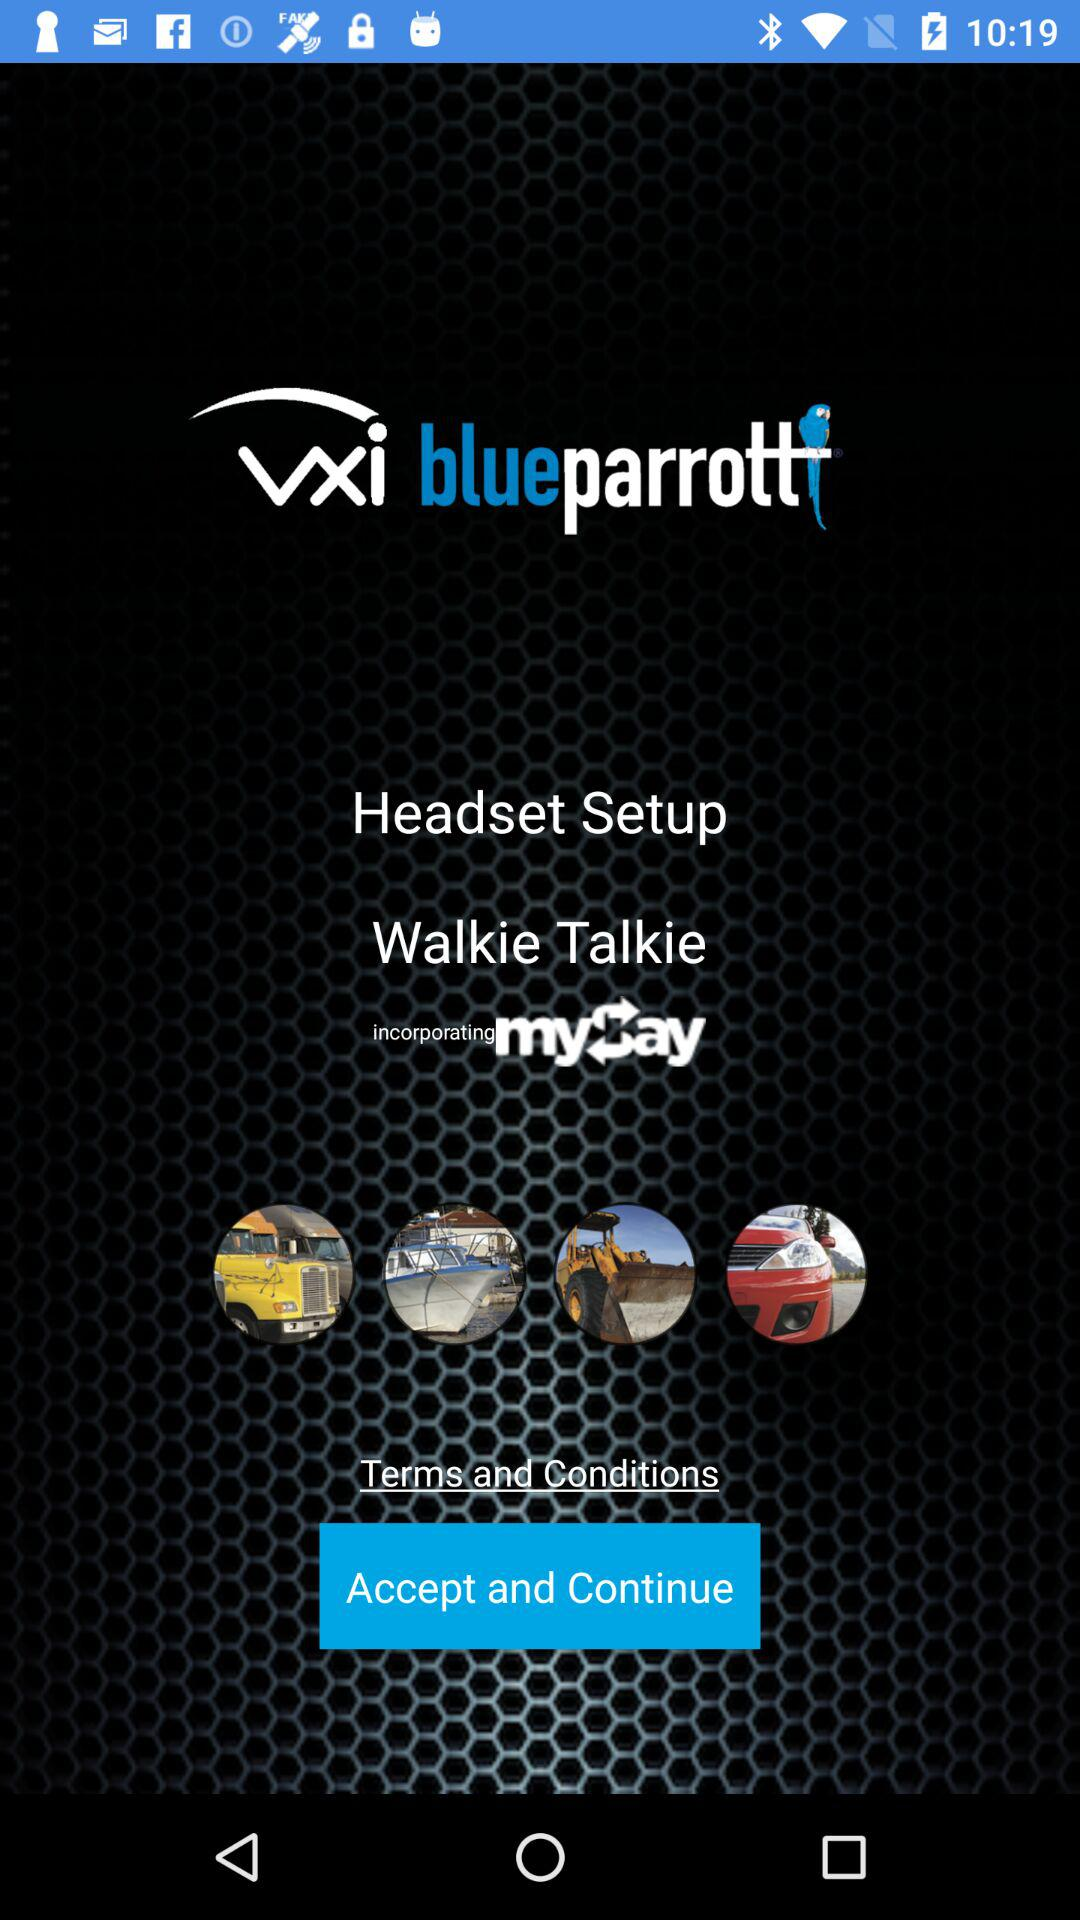What is the name of the application? The name of the application is "BlueParrott App". 